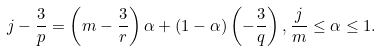Convert formula to latex. <formula><loc_0><loc_0><loc_500><loc_500>j - \frac { 3 } { p } = \left ( m - \frac { 3 } { r } \right ) \alpha + ( 1 - \alpha ) \left ( - \frac { 3 } { q } \right ) , \frac { j } { m } \leq \alpha \leq 1 .</formula> 